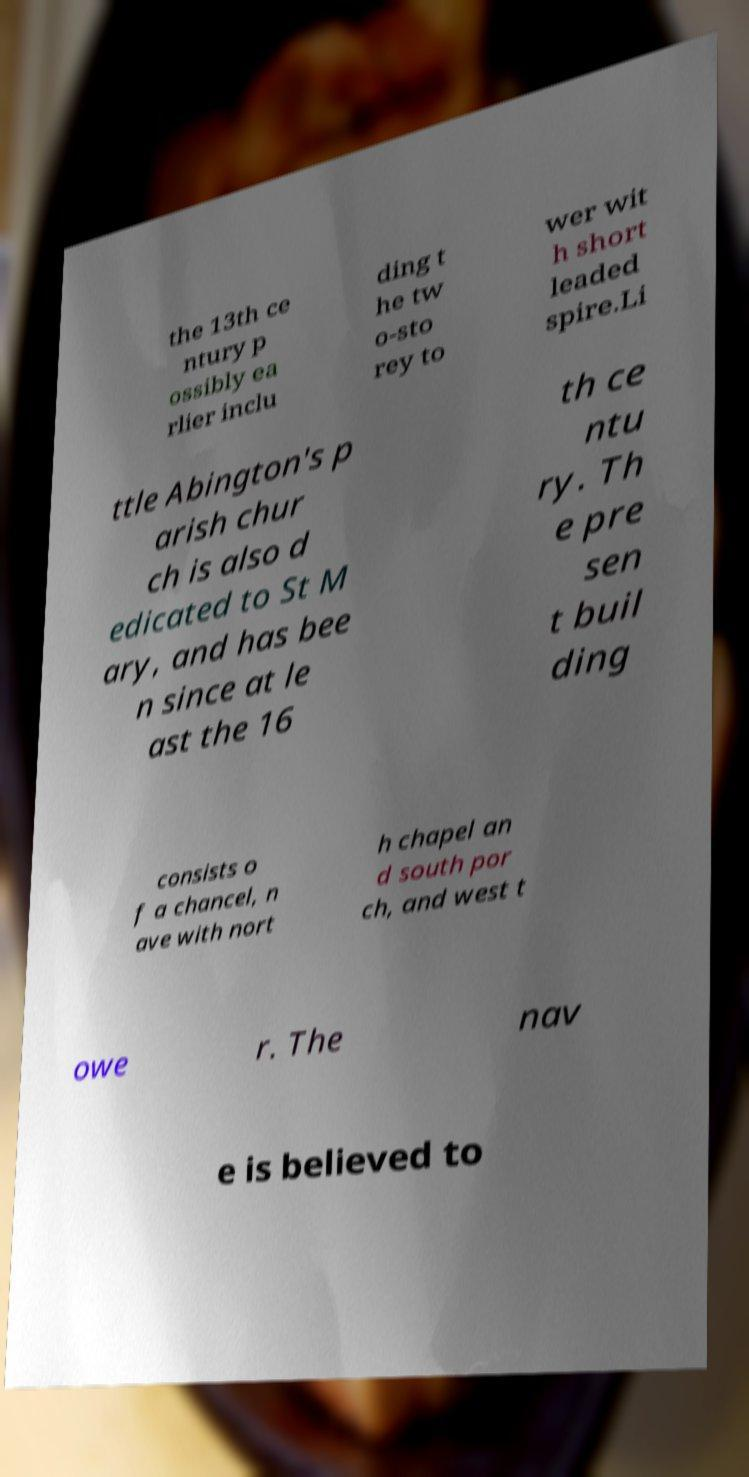Could you extract and type out the text from this image? the 13th ce ntury p ossibly ea rlier inclu ding t he tw o-sto rey to wer wit h short leaded spire.Li ttle Abington's p arish chur ch is also d edicated to St M ary, and has bee n since at le ast the 16 th ce ntu ry. Th e pre sen t buil ding consists o f a chancel, n ave with nort h chapel an d south por ch, and west t owe r. The nav e is believed to 